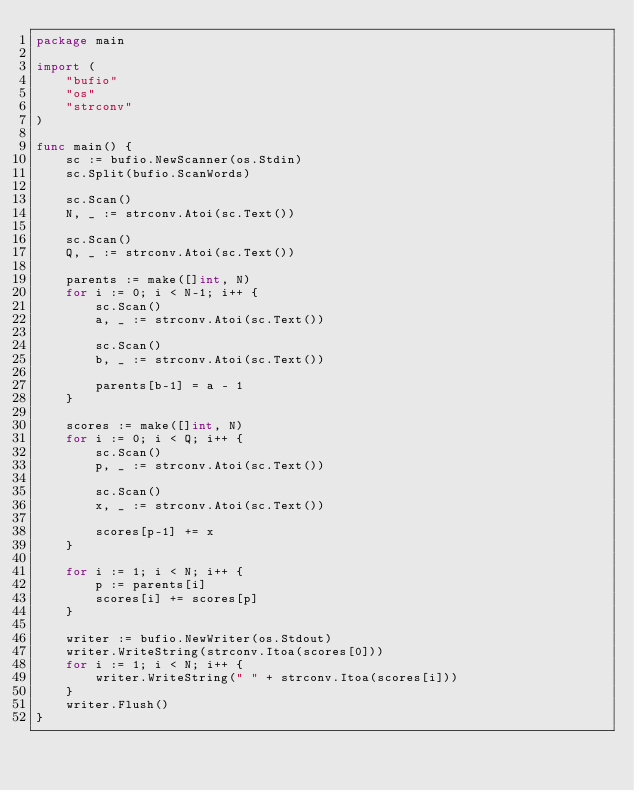<code> <loc_0><loc_0><loc_500><loc_500><_Go_>package main

import (
	"bufio"
	"os"
	"strconv"
)

func main() {
	sc := bufio.NewScanner(os.Stdin)
	sc.Split(bufio.ScanWords)

	sc.Scan()
	N, _ := strconv.Atoi(sc.Text())

	sc.Scan()
	Q, _ := strconv.Atoi(sc.Text())

	parents := make([]int, N)
	for i := 0; i < N-1; i++ {
		sc.Scan()
		a, _ := strconv.Atoi(sc.Text())

		sc.Scan()
		b, _ := strconv.Atoi(sc.Text())

		parents[b-1] = a - 1
	}

	scores := make([]int, N)
	for i := 0; i < Q; i++ {
		sc.Scan()
		p, _ := strconv.Atoi(sc.Text())

		sc.Scan()
		x, _ := strconv.Atoi(sc.Text())

		scores[p-1] += x
	}

	for i := 1; i < N; i++ {
		p := parents[i]
		scores[i] += scores[p]
	}

	writer := bufio.NewWriter(os.Stdout)
	writer.WriteString(strconv.Itoa(scores[0]))
	for i := 1; i < N; i++ {
		writer.WriteString(" " + strconv.Itoa(scores[i]))
	}
	writer.Flush()
}
</code> 